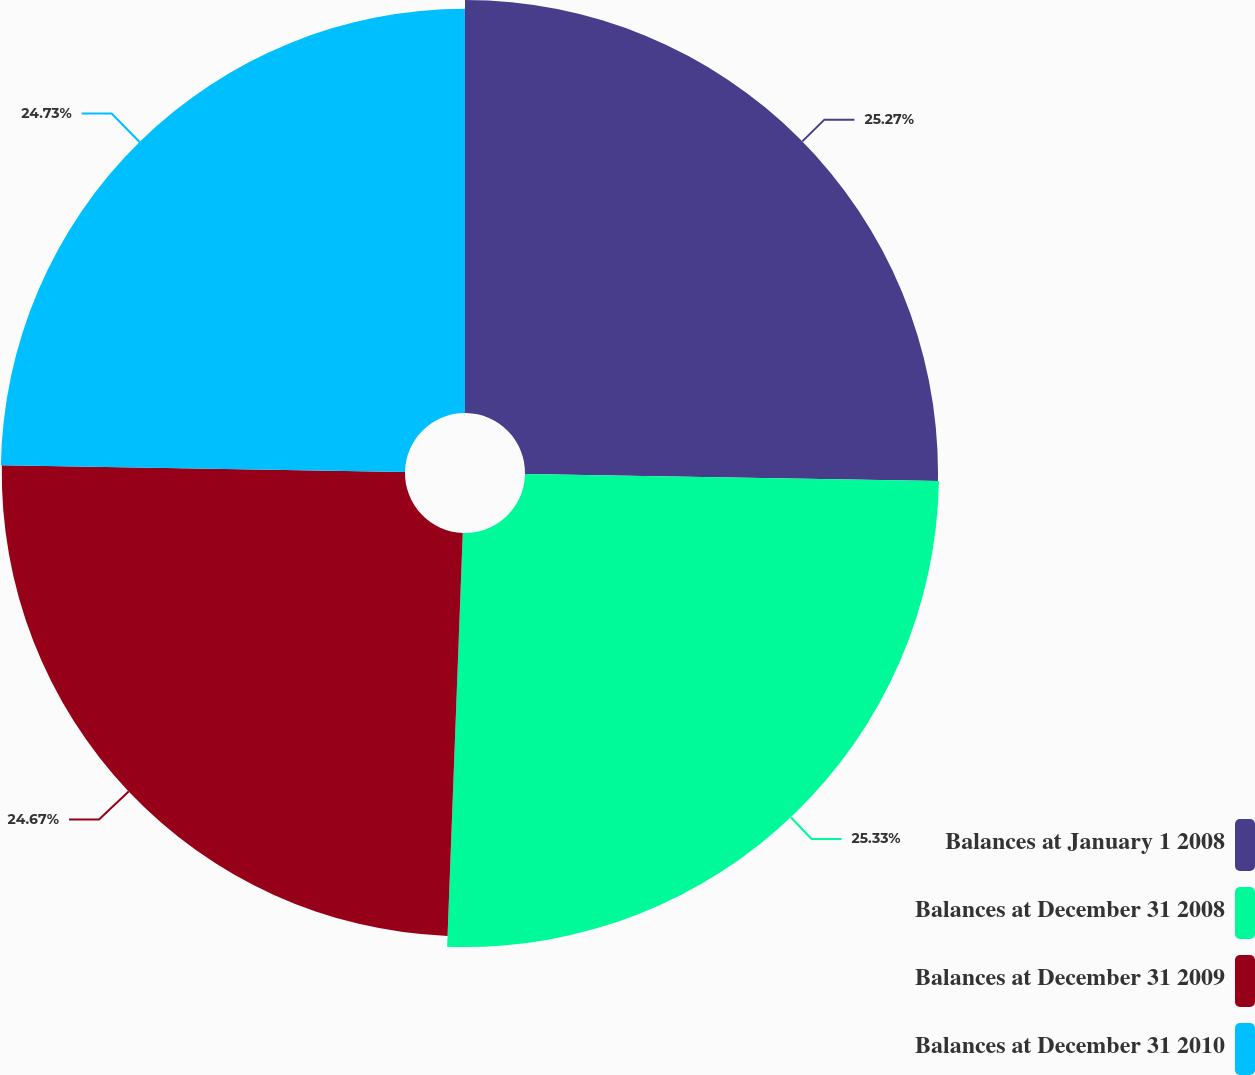Convert chart to OTSL. <chart><loc_0><loc_0><loc_500><loc_500><pie_chart><fcel>Balances at January 1 2008<fcel>Balances at December 31 2008<fcel>Balances at December 31 2009<fcel>Balances at December 31 2010<nl><fcel>25.27%<fcel>25.33%<fcel>24.67%<fcel>24.73%<nl></chart> 